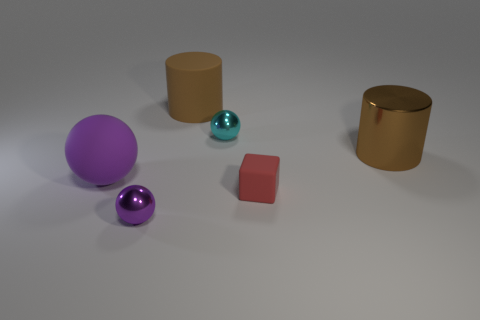Is there anything else that is the same shape as the red object?
Give a very brief answer. No. What is the color of the matte cube?
Your answer should be very brief. Red. Do the cube and the cyan sphere have the same size?
Keep it short and to the point. Yes. What number of things are either small metal objects or tiny purple blocks?
Your answer should be compact. 2. Are there an equal number of big purple balls on the left side of the large purple ball and yellow metal cylinders?
Give a very brief answer. Yes. Are there any tiny red rubber objects that are on the left side of the large brown cylinder that is on the left side of the big cylinder that is in front of the tiny cyan ball?
Your answer should be compact. No. There is a cube that is made of the same material as the large sphere; what color is it?
Your response must be concise. Red. There is a small sphere that is in front of the purple rubber ball; is it the same color as the cube?
Make the answer very short. No. How many cylinders are large objects or shiny objects?
Your answer should be very brief. 2. What size is the cylinder right of the tiny ball that is on the right side of the metallic object that is in front of the small red block?
Ensure brevity in your answer.  Large. 